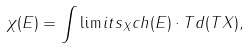Convert formula to latex. <formula><loc_0><loc_0><loc_500><loc_500>\chi ( E ) = \int \lim i t s _ { X } c h ( E ) \cdot T d ( T X ) ,</formula> 